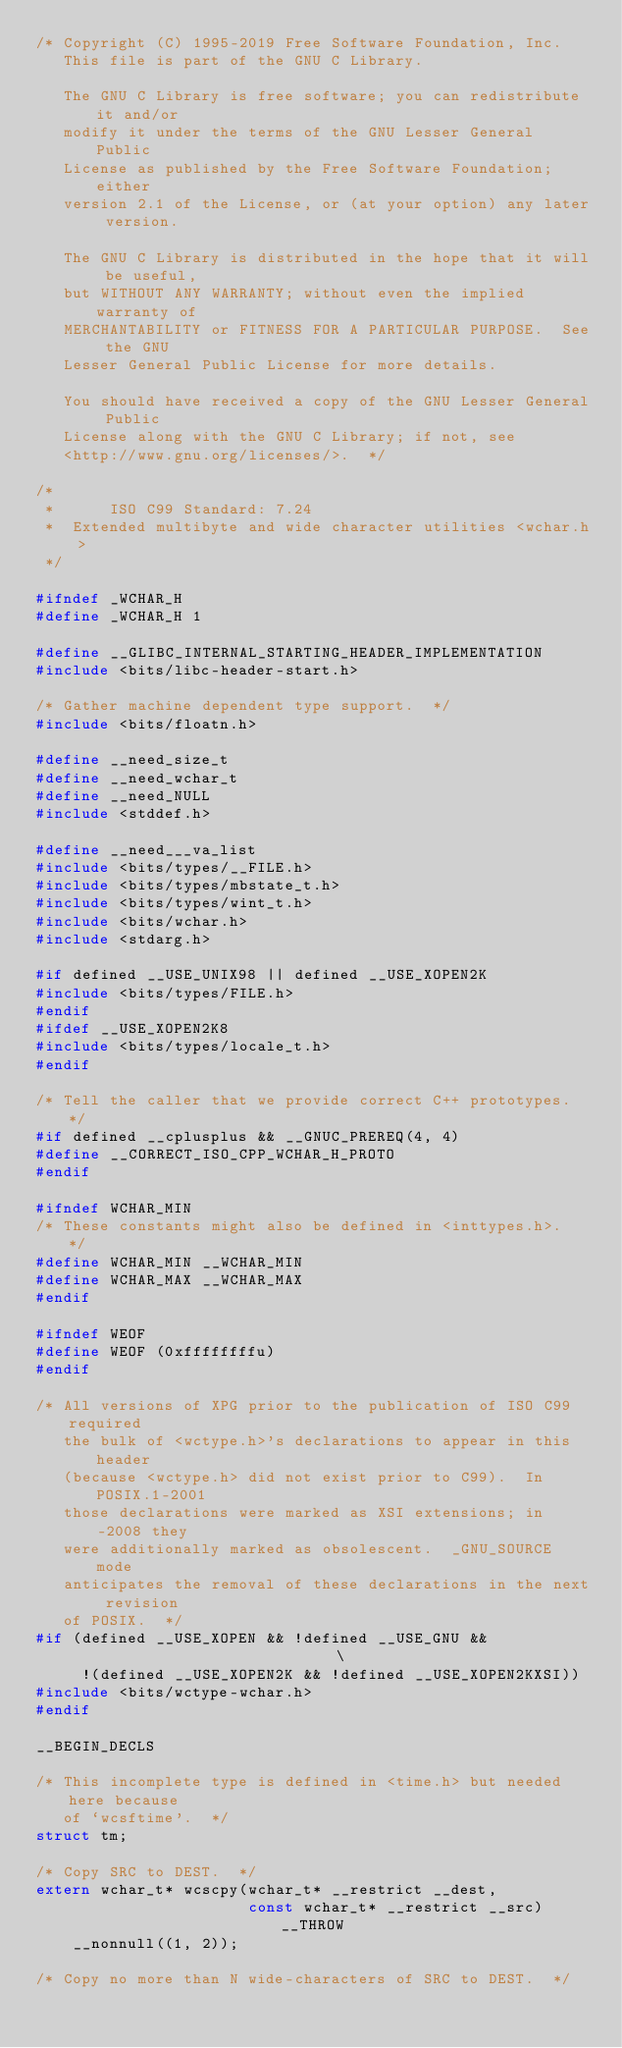Convert code to text. <code><loc_0><loc_0><loc_500><loc_500><_C_>/* Copyright (C) 1995-2019 Free Software Foundation, Inc.
   This file is part of the GNU C Library.

   The GNU C Library is free software; you can redistribute it and/or
   modify it under the terms of the GNU Lesser General Public
   License as published by the Free Software Foundation; either
   version 2.1 of the License, or (at your option) any later version.

   The GNU C Library is distributed in the hope that it will be useful,
   but WITHOUT ANY WARRANTY; without even the implied warranty of
   MERCHANTABILITY or FITNESS FOR A PARTICULAR PURPOSE.  See the GNU
   Lesser General Public License for more details.

   You should have received a copy of the GNU Lesser General Public
   License along with the GNU C Library; if not, see
   <http://www.gnu.org/licenses/>.  */

/*
 *      ISO C99 Standard: 7.24
 *	Extended multibyte and wide character utilities	<wchar.h>
 */

#ifndef _WCHAR_H
#define _WCHAR_H 1

#define __GLIBC_INTERNAL_STARTING_HEADER_IMPLEMENTATION
#include <bits/libc-header-start.h>

/* Gather machine dependent type support.  */
#include <bits/floatn.h>

#define __need_size_t
#define __need_wchar_t
#define __need_NULL
#include <stddef.h>

#define __need___va_list
#include <bits/types/__FILE.h>
#include <bits/types/mbstate_t.h>
#include <bits/types/wint_t.h>
#include <bits/wchar.h>
#include <stdarg.h>

#if defined __USE_UNIX98 || defined __USE_XOPEN2K
#include <bits/types/FILE.h>
#endif
#ifdef __USE_XOPEN2K8
#include <bits/types/locale_t.h>
#endif

/* Tell the caller that we provide correct C++ prototypes.  */
#if defined __cplusplus && __GNUC_PREREQ(4, 4)
#define __CORRECT_ISO_CPP_WCHAR_H_PROTO
#endif

#ifndef WCHAR_MIN
/* These constants might also be defined in <inttypes.h>.  */
#define WCHAR_MIN __WCHAR_MIN
#define WCHAR_MAX __WCHAR_MAX
#endif

#ifndef WEOF
#define WEOF (0xffffffffu)
#endif

/* All versions of XPG prior to the publication of ISO C99 required
   the bulk of <wctype.h>'s declarations to appear in this header
   (because <wctype.h> did not exist prior to C99).  In POSIX.1-2001
   those declarations were marked as XSI extensions; in -2008 they
   were additionally marked as obsolescent.  _GNU_SOURCE mode
   anticipates the removal of these declarations in the next revision
   of POSIX.  */
#if (defined __USE_XOPEN && !defined __USE_GNU &&                              \
     !(defined __USE_XOPEN2K && !defined __USE_XOPEN2KXSI))
#include <bits/wctype-wchar.h>
#endif

__BEGIN_DECLS

/* This incomplete type is defined in <time.h> but needed here because
   of `wcsftime'.  */
struct tm;

/* Copy SRC to DEST.  */
extern wchar_t* wcscpy(wchar_t* __restrict __dest,
                       const wchar_t* __restrict __src) __THROW
    __nonnull((1, 2));

/* Copy no more than N wide-characters of SRC to DEST.  */</code> 